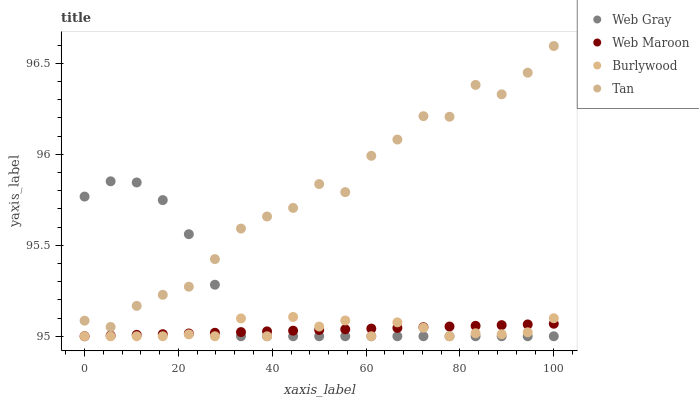Does Burlywood have the minimum area under the curve?
Answer yes or no. Yes. Does Tan have the maximum area under the curve?
Answer yes or no. Yes. Does Web Gray have the minimum area under the curve?
Answer yes or no. No. Does Web Gray have the maximum area under the curve?
Answer yes or no. No. Is Web Maroon the smoothest?
Answer yes or no. Yes. Is Tan the roughest?
Answer yes or no. Yes. Is Web Gray the smoothest?
Answer yes or no. No. Is Web Gray the roughest?
Answer yes or no. No. Does Burlywood have the lowest value?
Answer yes or no. Yes. Does Tan have the lowest value?
Answer yes or no. No. Does Tan have the highest value?
Answer yes or no. Yes. Does Web Gray have the highest value?
Answer yes or no. No. Is Web Maroon less than Tan?
Answer yes or no. Yes. Is Tan greater than Web Maroon?
Answer yes or no. Yes. Does Web Maroon intersect Burlywood?
Answer yes or no. Yes. Is Web Maroon less than Burlywood?
Answer yes or no. No. Is Web Maroon greater than Burlywood?
Answer yes or no. No. Does Web Maroon intersect Tan?
Answer yes or no. No. 